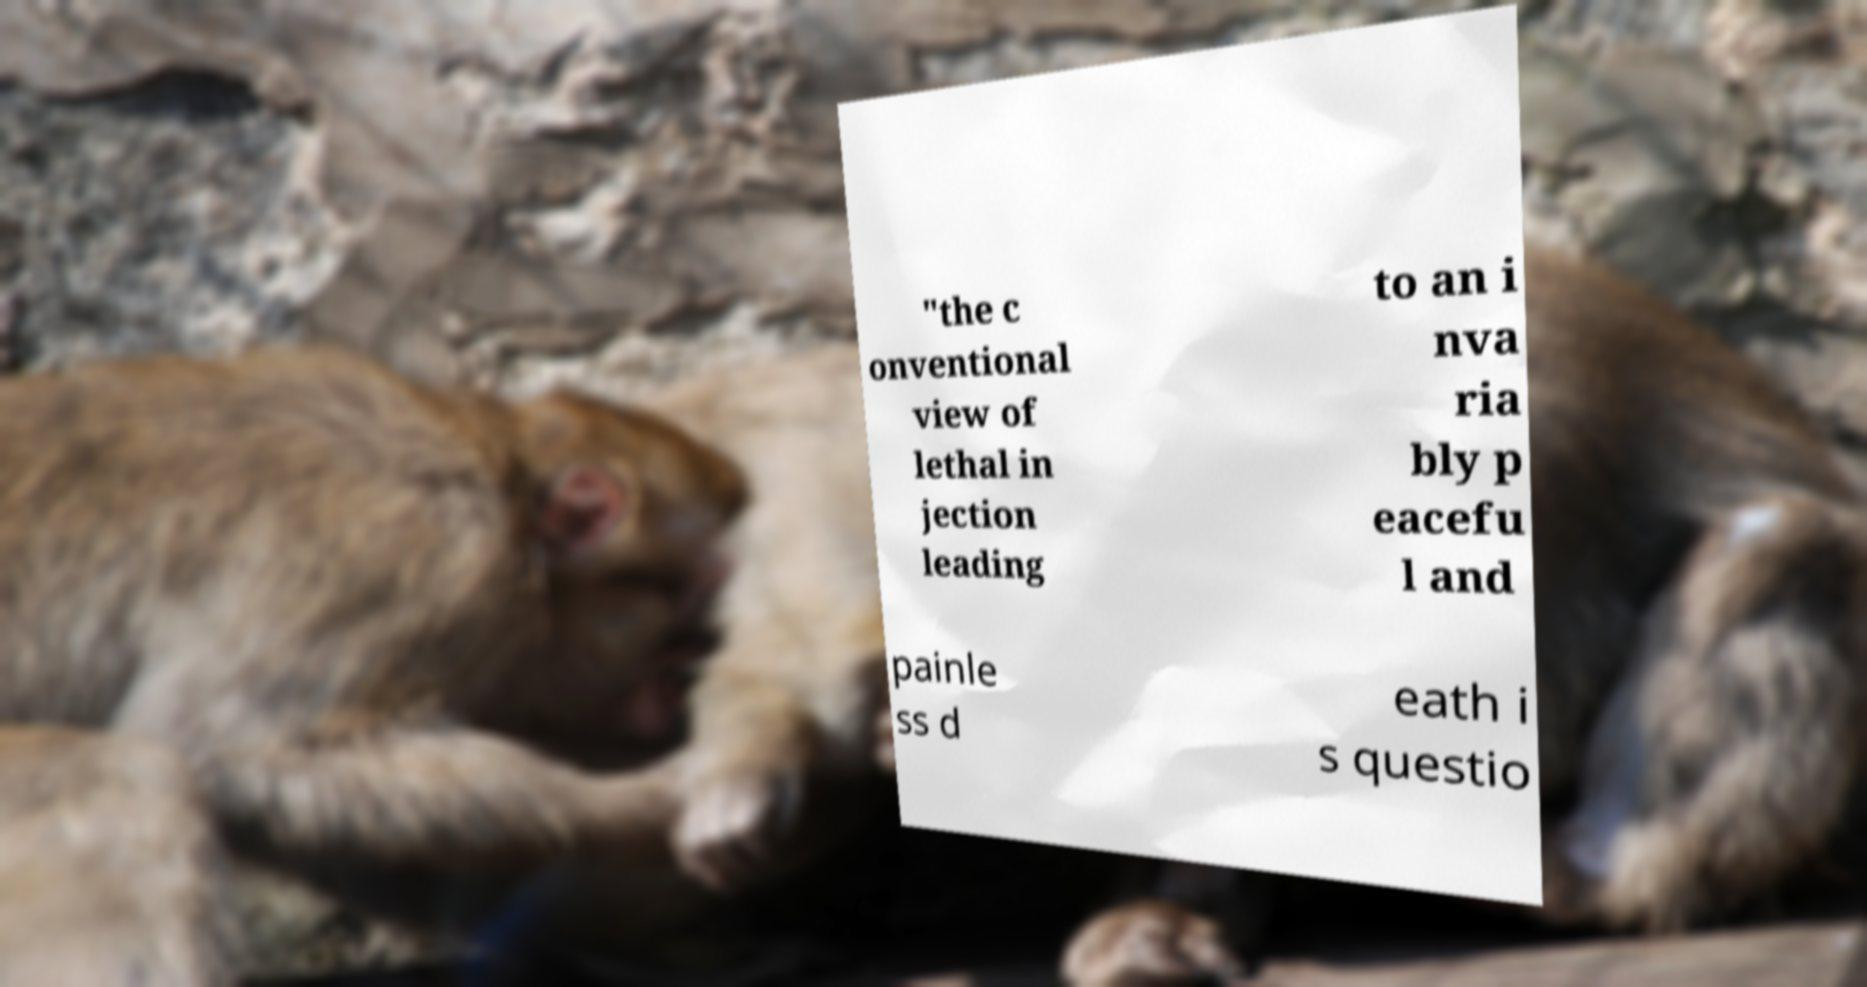Could you extract and type out the text from this image? "the c onventional view of lethal in jection leading to an i nva ria bly p eacefu l and painle ss d eath i s questio 